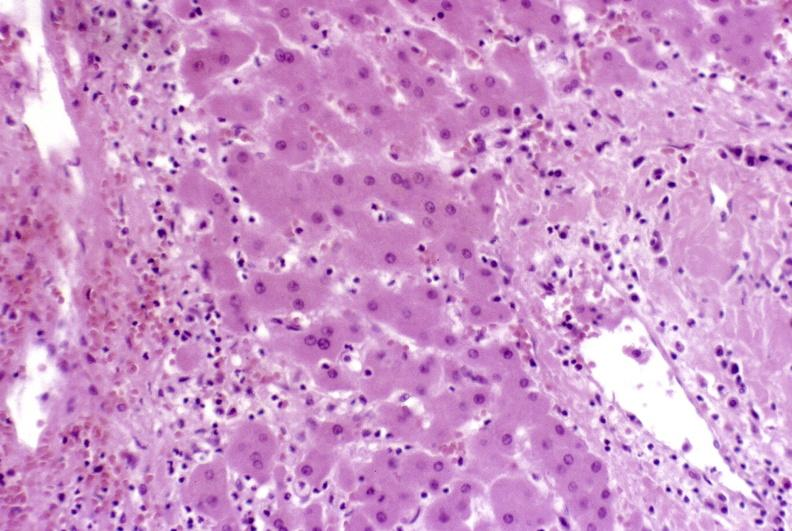s liver present?
Answer the question using a single word or phrase. Yes 